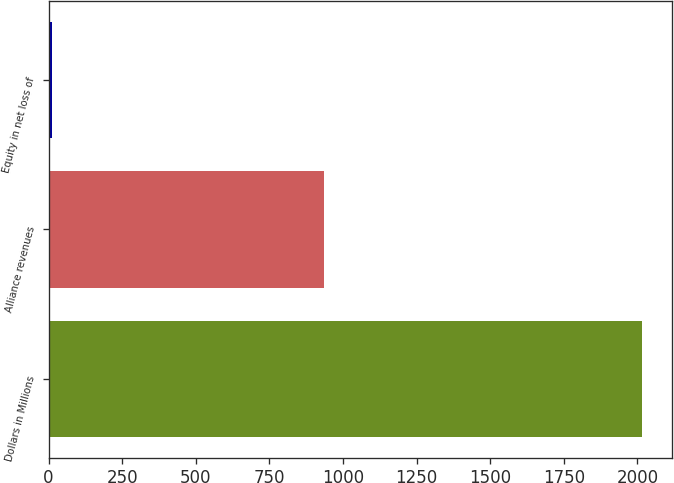Convert chart. <chart><loc_0><loc_0><loc_500><loc_500><bar_chart><fcel>Dollars in Millions<fcel>Alliance revenues<fcel>Equity in net loss of<nl><fcel>2016<fcel>934<fcel>12<nl></chart> 